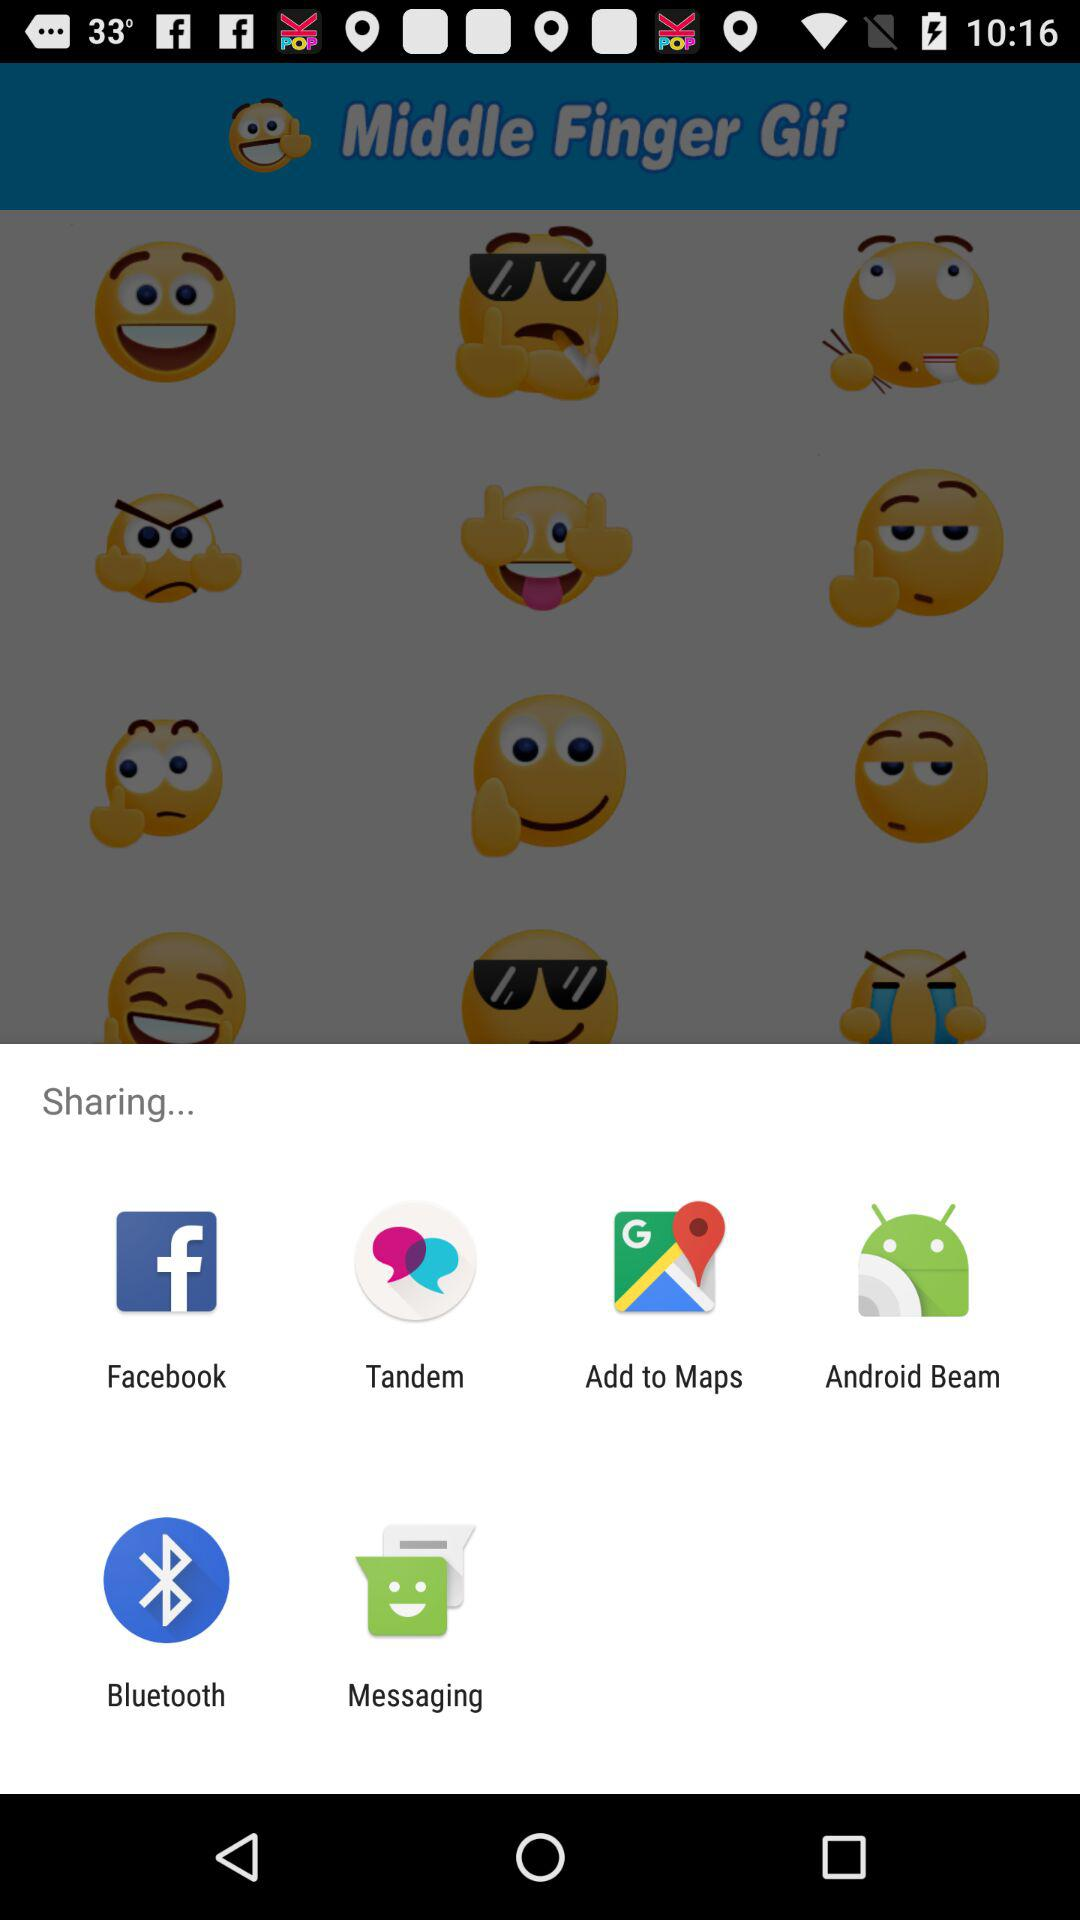What are the options to share? The options to share are "Facebook", "Tandem", "Add to Maps", "Android Beam", "Bluetooth" and "Messaging". 